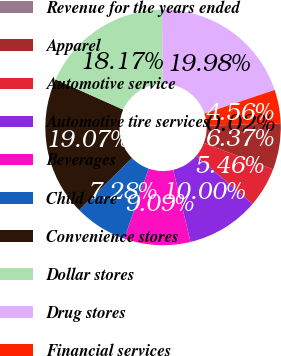Convert chart to OTSL. <chart><loc_0><loc_0><loc_500><loc_500><pie_chart><fcel>Revenue for the years ended<fcel>Apparel<fcel>Automotive service<fcel>Automotive tire services<fcel>Beverages<fcel>Child care<fcel>Convenience stores<fcel>Dollar stores<fcel>Drug stores<fcel>Financial services<nl><fcel>0.02%<fcel>6.37%<fcel>5.46%<fcel>10.0%<fcel>9.09%<fcel>7.28%<fcel>19.07%<fcel>18.17%<fcel>19.98%<fcel>4.56%<nl></chart> 